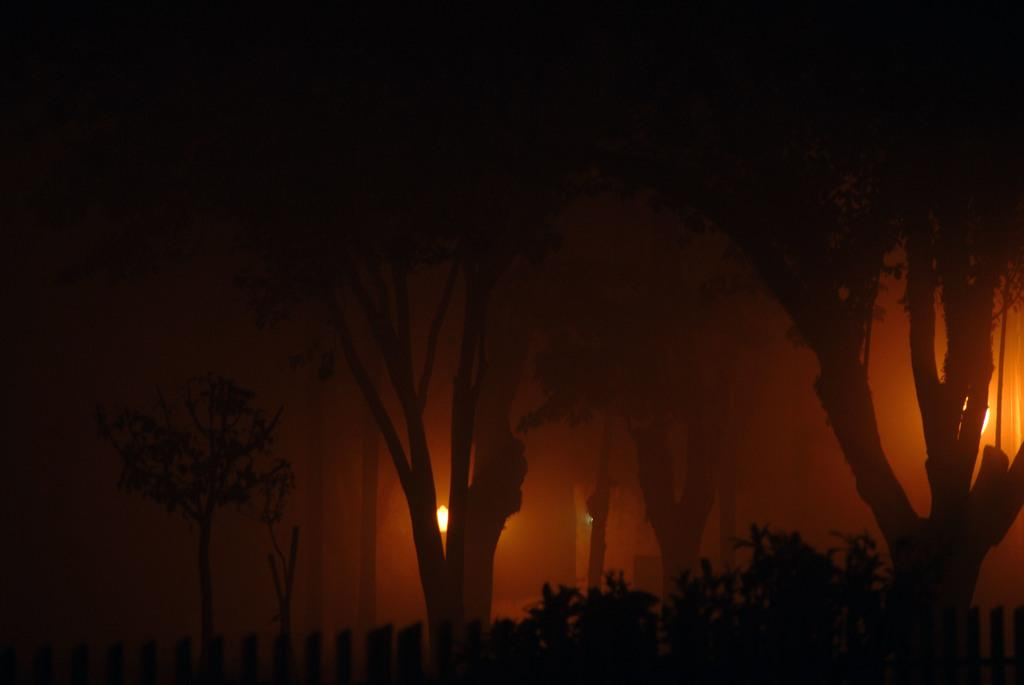What type of vegetation can be seen in the image? There are trees and plants in the image. Are there any artificial light sources in the image? Yes, there are lights in the image. What type of stream can be seen in the image? There is no stream present in the image. What title is given to the image? The image does not have a title, as it is not a piece of artwork or a photograph with a specific name. 